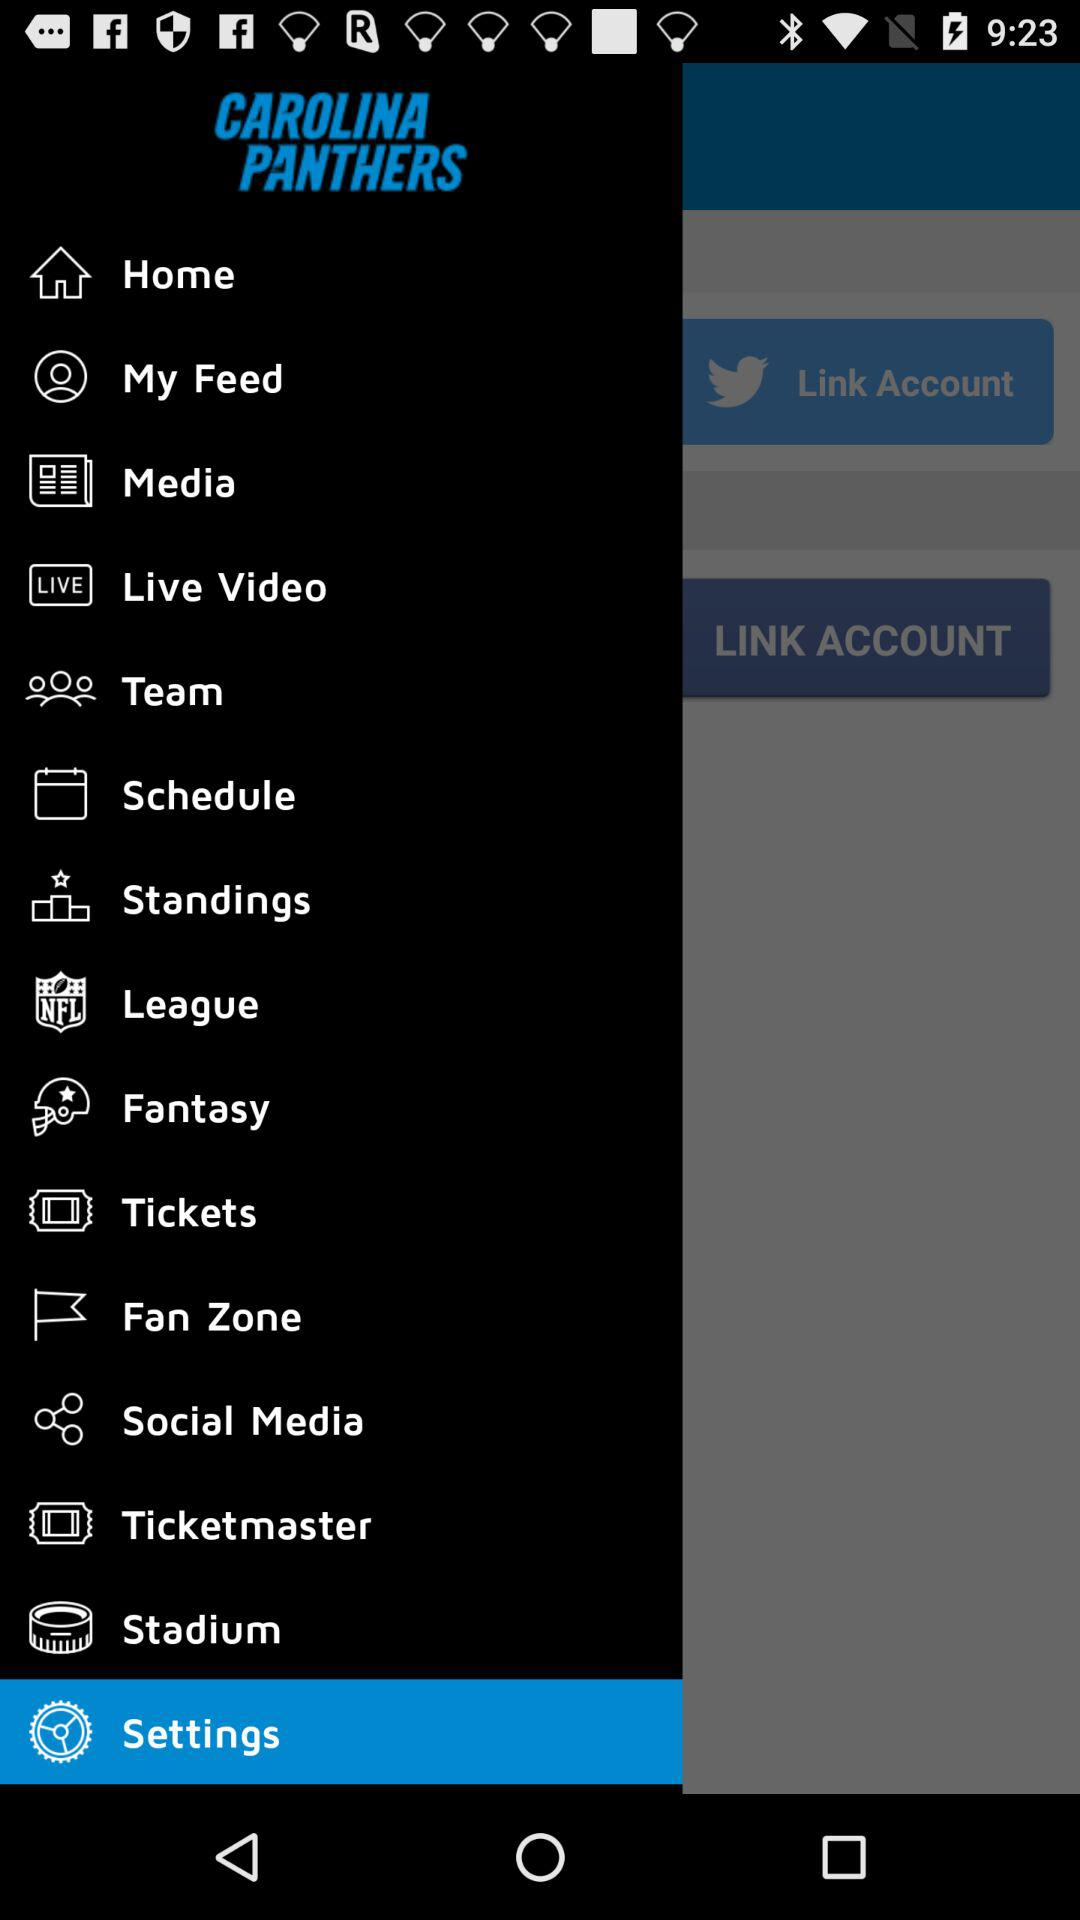What is the application name? The application name is "CAROLINA PANTHERS". 